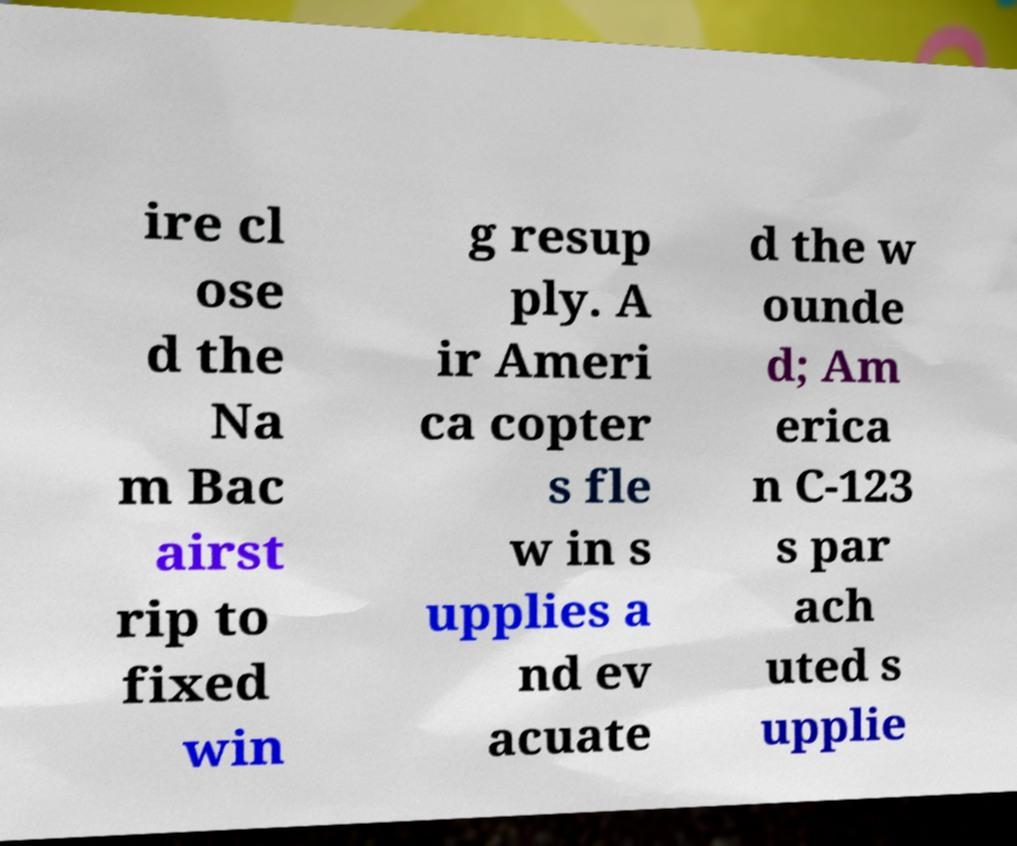Could you extract and type out the text from this image? ire cl ose d the Na m Bac airst rip to fixed win g resup ply. A ir Ameri ca copter s fle w in s upplies a nd ev acuate d the w ounde d; Am erica n C-123 s par ach uted s upplie 